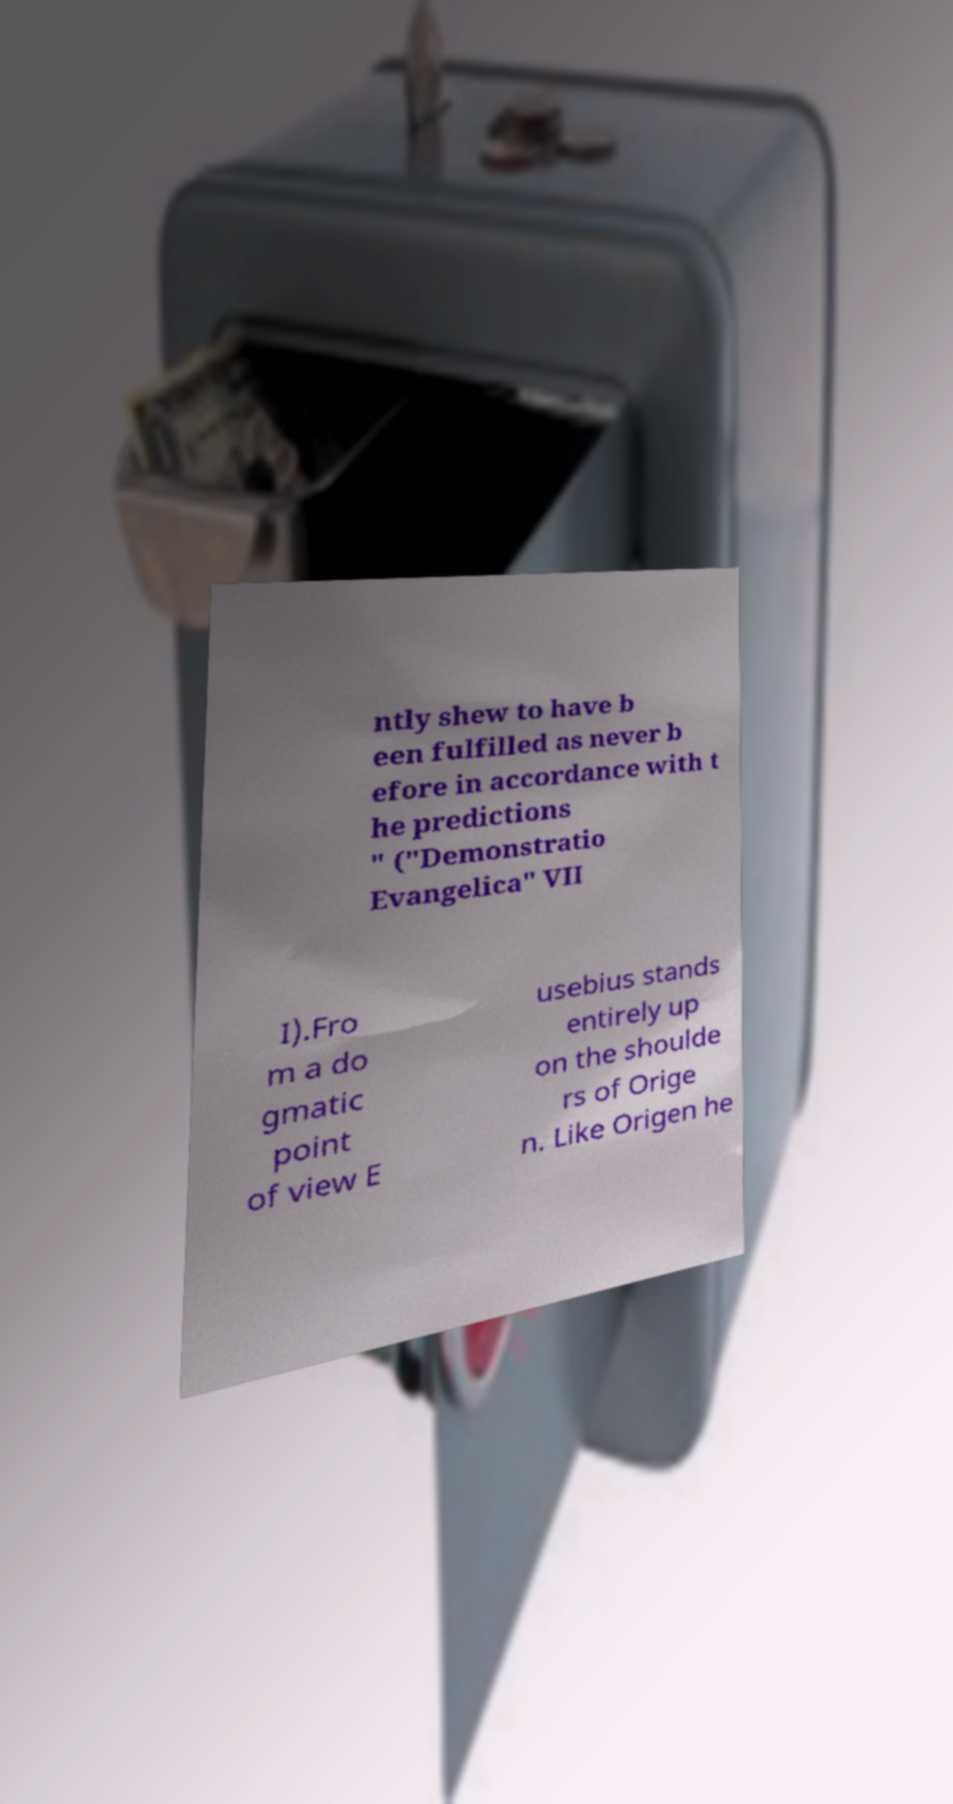Please read and relay the text visible in this image. What does it say? ntly shew to have b een fulfilled as never b efore in accordance with t he predictions " ("Demonstratio Evangelica" VII I).Fro m a do gmatic point of view E usebius stands entirely up on the shoulde rs of Orige n. Like Origen he 